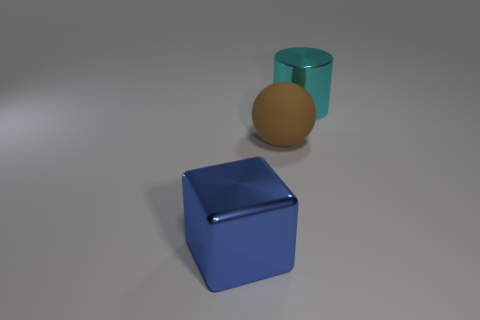Is the number of blue shiny objects less than the number of blue matte objects?
Make the answer very short. No. There is a brown rubber thing; does it have the same shape as the shiny object left of the brown matte thing?
Make the answer very short. No. The thing that is both to the left of the big cyan object and to the right of the blue object has what shape?
Give a very brief answer. Sphere. Are there the same number of big cylinders that are to the right of the big cylinder and matte objects in front of the large ball?
Give a very brief answer. Yes. Do the metal object that is behind the big blue metallic object and the large brown object have the same shape?
Your answer should be compact. No. How many cyan things are either matte balls or blocks?
Ensure brevity in your answer.  0. The large metallic object that is behind the big brown rubber ball has what shape?
Provide a succinct answer. Cylinder. Is there a brown sphere made of the same material as the cyan cylinder?
Keep it short and to the point. No. Is the cylinder the same size as the metal block?
Make the answer very short. Yes. What number of spheres are either small gray things or cyan things?
Provide a succinct answer. 0. 